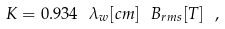Convert formula to latex. <formula><loc_0><loc_0><loc_500><loc_500>K = 0 . 9 3 4 \ \lambda _ { w } [ { c m } ] \ B _ { r m s } [ { T } ] \ ,</formula> 